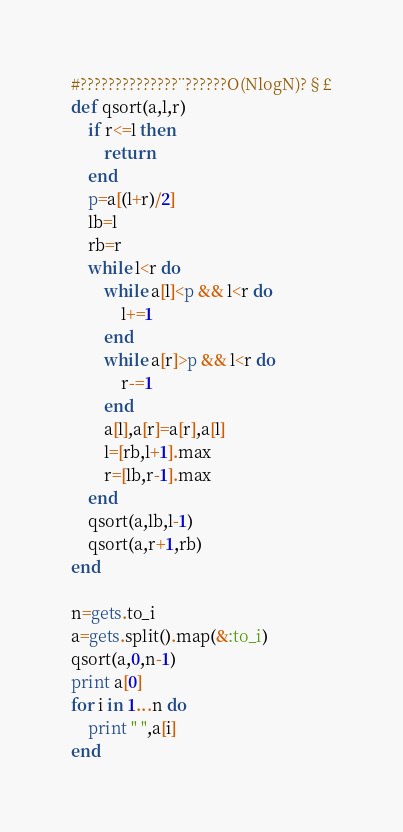<code> <loc_0><loc_0><loc_500><loc_500><_Ruby_>#??????????????¨??????O(NlogN)?§£
def qsort(a,l,r)
	if r<=l then
		return
	end
	p=a[(l+r)/2]
	lb=l
	rb=r
	while l<r do
		while a[l]<p && l<r do
			l+=1
		end
		while a[r]>p && l<r do
			r-=1
		end
		a[l],a[r]=a[r],a[l]
		l=[rb,l+1].max
		r=[lb,r-1].max
	end
	qsort(a,lb,l-1)
	qsort(a,r+1,rb)
end

n=gets.to_i
a=gets.split().map(&:to_i)
qsort(a,0,n-1)
print a[0]
for i in 1...n do
	print " ",a[i]
end</code> 